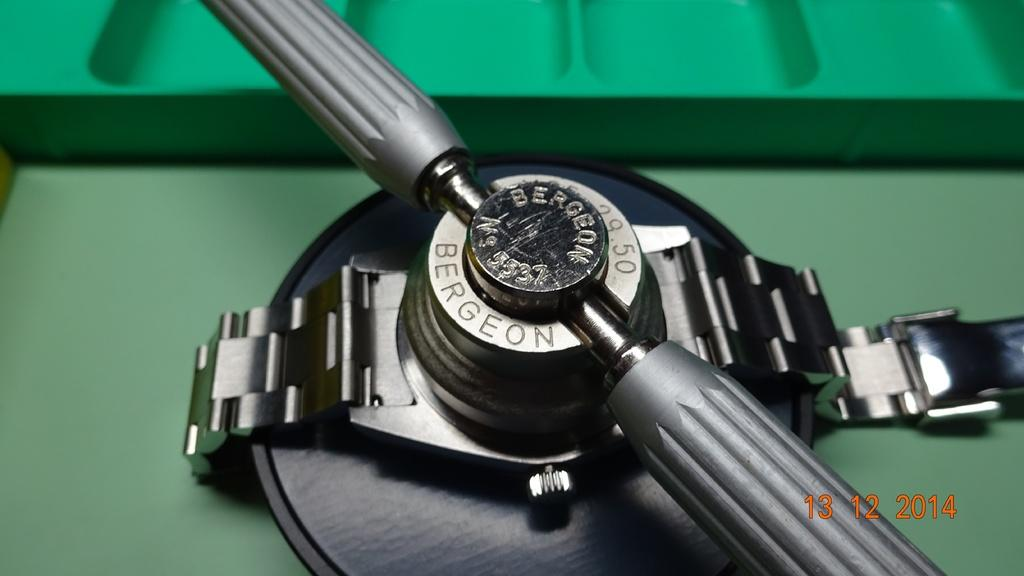<image>
Write a terse but informative summary of the picture. A photograph taken on December 12, 2014 shows a silver band from a watch. 